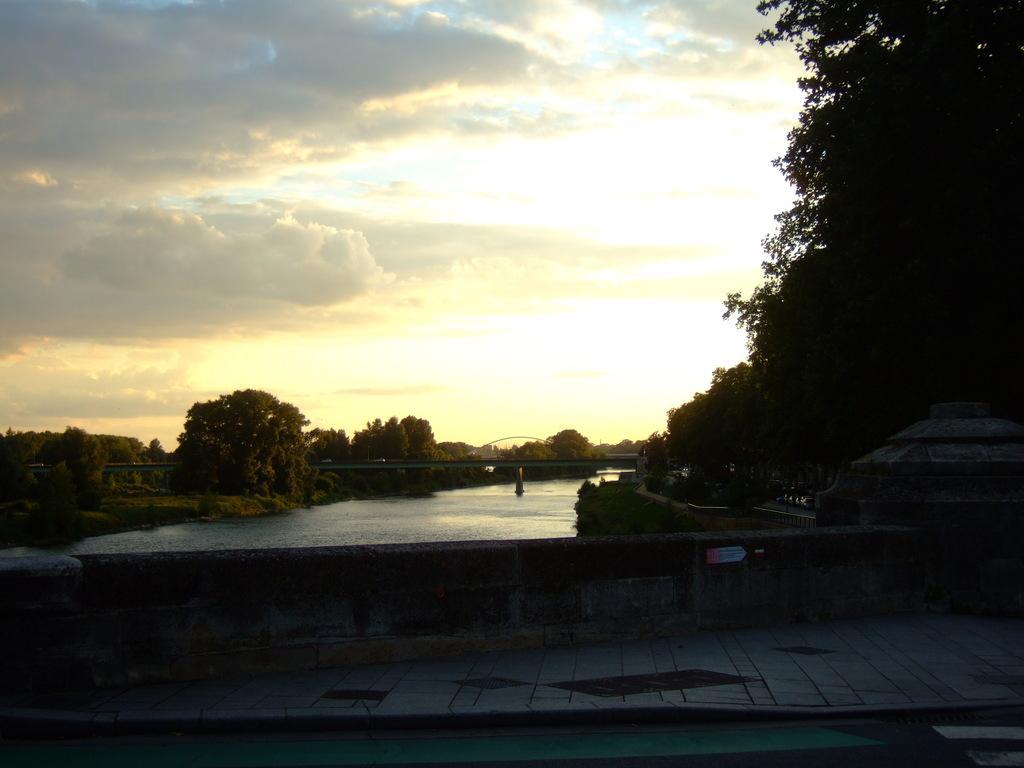In one or two sentences, can you explain what this image depicts? In this image, there are trees, plants, bridge, pillar, walkway and the water. There is the cloudy sky in the background. 